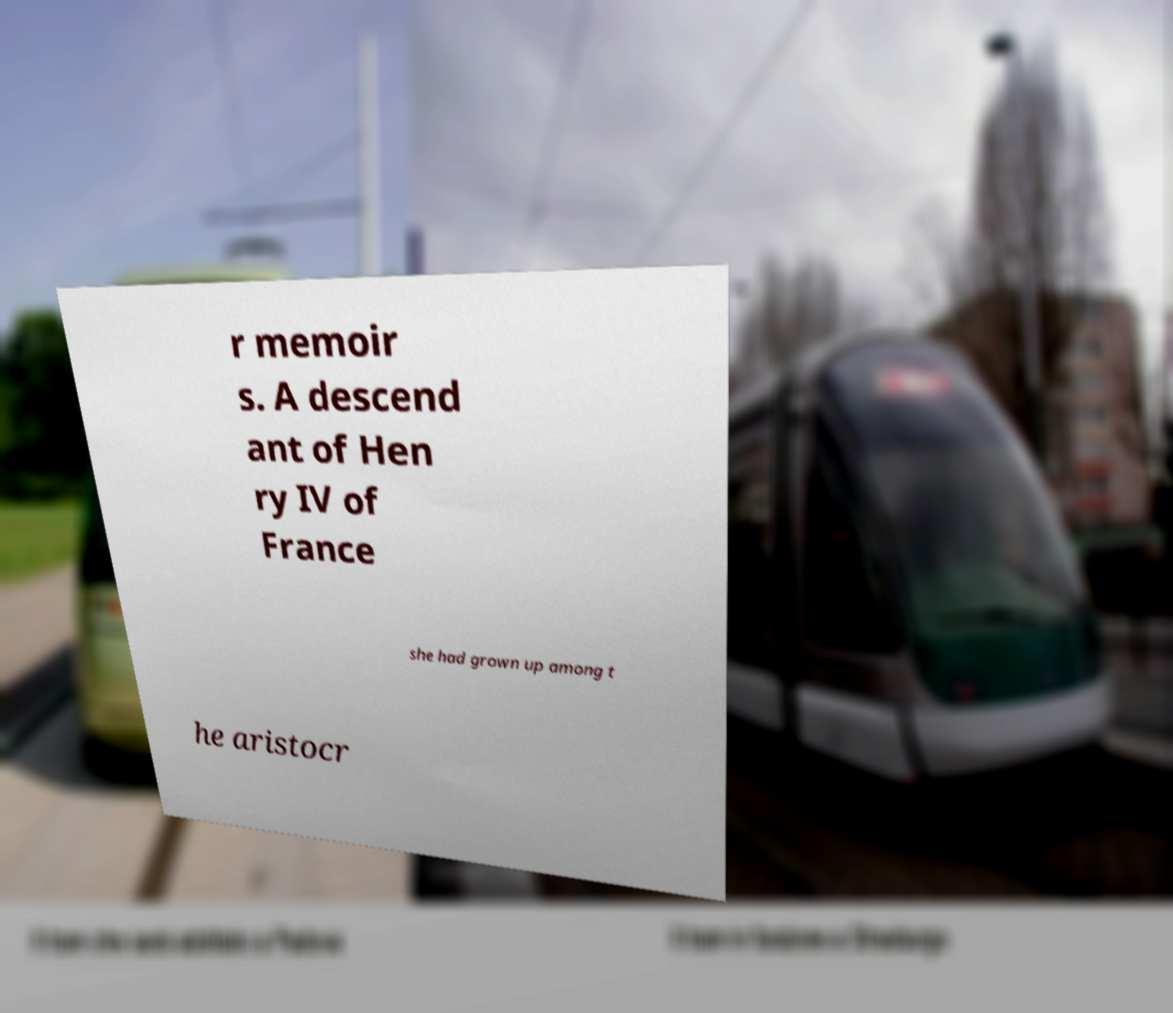I need the written content from this picture converted into text. Can you do that? r memoir s. A descend ant of Hen ry IV of France she had grown up among t he aristocr 